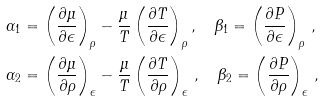<formula> <loc_0><loc_0><loc_500><loc_500>\alpha _ { 1 } & = \left ( \frac { \partial \mu } { \partial \epsilon } \right ) _ { \rho } - \frac { \mu } { T } \left ( \frac { \partial T } { \partial \epsilon } \right ) _ { \rho } , \quad \beta _ { 1 } = \left ( \frac { \partial P } { \partial \epsilon } \right ) _ { \rho } \, , \\ \alpha _ { 2 } & = \left ( \frac { \partial \mu } { \partial \rho } \right ) _ { \epsilon } - \frac { \mu } { T } \left ( \frac { \partial T } { \partial \rho } \right ) _ { \epsilon } \, , \quad \beta _ { 2 } = \left ( \frac { \partial P } { \partial \rho } \right ) _ { \epsilon } \, ,</formula> 